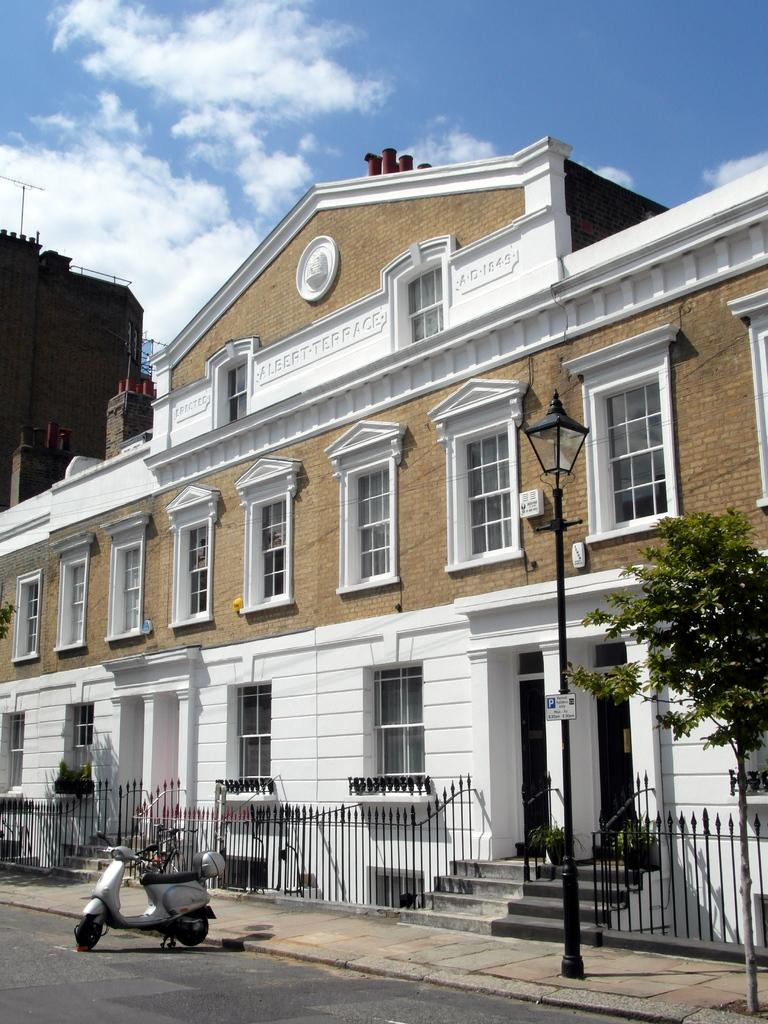What type of structures can be seen in the image? There are buildings in the image. What object is present near the buildings? There is a pole in the image. What is attached to the pole? There is a light attached to the pole. What type of vegetation is present in the image? There is a tree in the image. What architectural feature is present in front of the building? A fence is present in front of the building. What mode of transportation is visible in the image? There is a scooter in front of the building. What can be seen in the background of the image? Clouds are visible in the background of the image. What type of comb is being used to style the tree in the image? There is no comb present in the image, and the tree is not being styled. What scent can be detected from the scooter in the image? There is no mention of a scent in the image, and the scooter is not associated with any particular smell. 